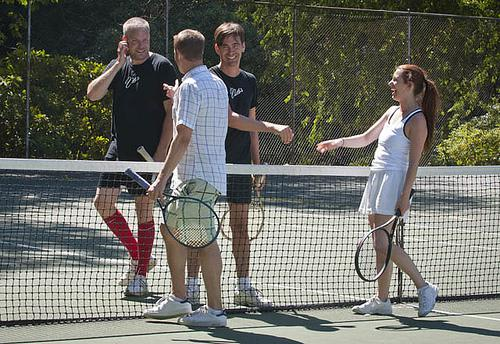Question: how many men are in this picture?
Choices:
A. More than fifty.
B. Sixteen.
C. Three.
D. Six.
Answer with the letter. Answer: C Question: where is the woman's tennis racket?
Choices:
A. On the ground.
B. Under her arm.
C. On the bench.
D. In her hand.
Answer with the letter. Answer: D Question: what sport is portrayed?
Choices:
A. Tennis.
B. Gymnastics.
C. Basketball.
D. Volleyball.
Answer with the letter. Answer: A Question: what color outfit is the woman wearing?
Choices:
A. Brown.
B. Red.
C. White.
D. Yellow and orange.
Answer with the letter. Answer: C Question: who is on the woman's team?
Choices:
A. Man in plaid shirt.
B. The woman in green.
C. The man in blue.
D. The woman in stripes.
Answer with the letter. Answer: A Question: where are these people standing?
Choices:
A. In a garden.
B. Tennis court.
C. On a sidewalk.
D. On a pier.
Answer with the letter. Answer: B 